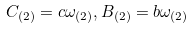<formula> <loc_0><loc_0><loc_500><loc_500>C _ { ( 2 ) } = c \omega _ { ( 2 ) } , B _ { ( 2 ) } = b \omega _ { ( 2 ) }</formula> 